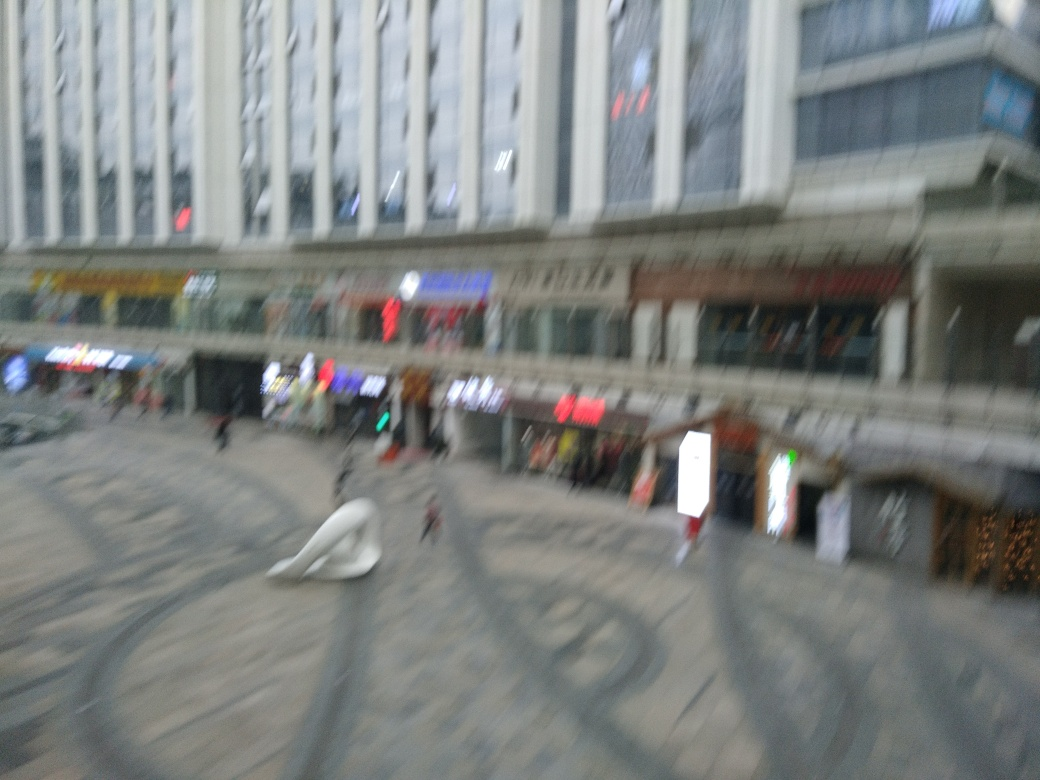What time of day does this image seem to depict? The image seems to capture a time during the late afternoon, based on the natural lighting and the active, yet not overly crowded, atmosphere outside of the shops and restaurants. 